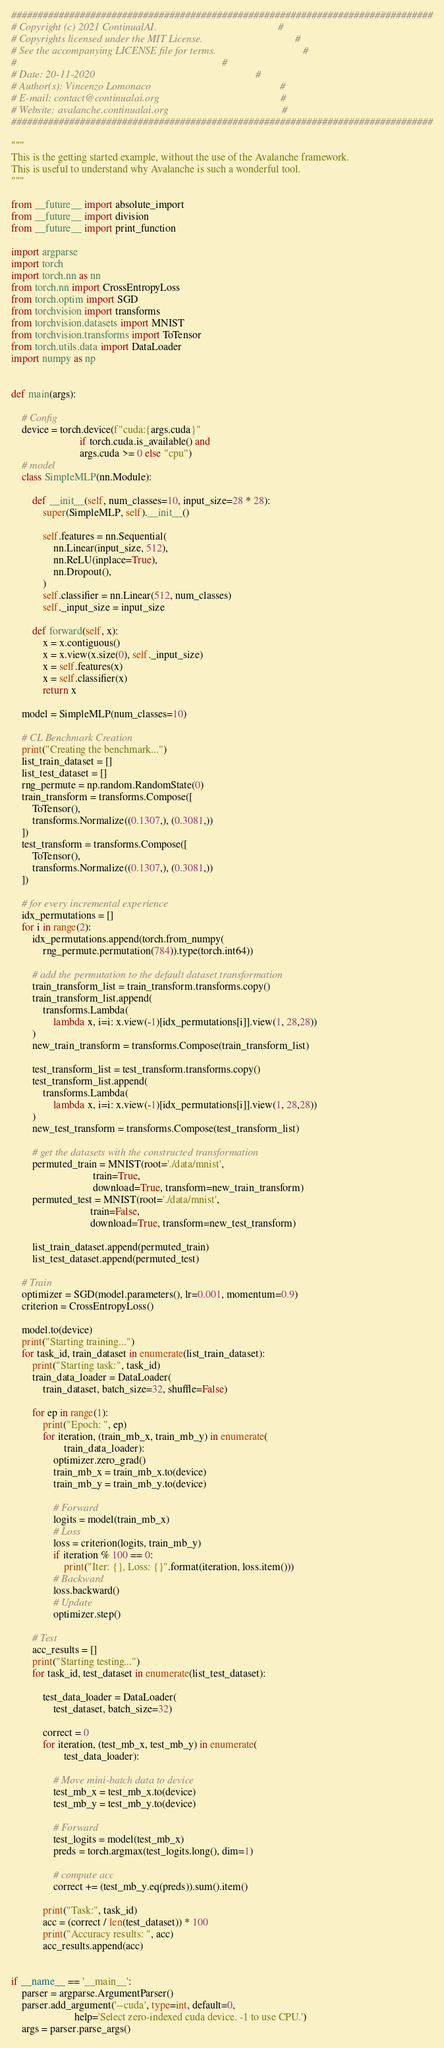<code> <loc_0><loc_0><loc_500><loc_500><_Python_>################################################################################
# Copyright (c) 2021 ContinualAI.                                              #
# Copyrights licensed under the MIT License.                                   #
# See the accompanying LICENSE file for terms.                                 #
#                                                                              #
# Date: 20-11-2020                                                             #
# Author(s): Vincenzo Lomonaco                                                 #
# E-mail: contact@continualai.org                                              #
# Website: avalanche.continualai.org                                           #
################################################################################

"""
This is the getting started example, without the use of the Avalanche framework.
This is useful to understand why Avalanche is such a wonderful tool.
"""

from __future__ import absolute_import
from __future__ import division
from __future__ import print_function

import argparse
import torch
import torch.nn as nn
from torch.nn import CrossEntropyLoss
from torch.optim import SGD
from torchvision import transforms
from torchvision.datasets import MNIST
from torchvision.transforms import ToTensor
from torch.utils.data import DataLoader
import numpy as np


def main(args):

    # Config
    device = torch.device(f"cuda:{args.cuda}"
                          if torch.cuda.is_available() and
                          args.cuda >= 0 else "cpu")
    # model
    class SimpleMLP(nn.Module):

        def __init__(self, num_classes=10, input_size=28 * 28):
            super(SimpleMLP, self).__init__()

            self.features = nn.Sequential(
                nn.Linear(input_size, 512),
                nn.ReLU(inplace=True),
                nn.Dropout(),
            )
            self.classifier = nn.Linear(512, num_classes)
            self._input_size = input_size

        def forward(self, x):
            x = x.contiguous()
            x = x.view(x.size(0), self._input_size)
            x = self.features(x)
            x = self.classifier(x)
            return x

    model = SimpleMLP(num_classes=10)

    # CL Benchmark Creation
    print("Creating the benchmark...")
    list_train_dataset = []
    list_test_dataset = []
    rng_permute = np.random.RandomState(0)
    train_transform = transforms.Compose([
        ToTensor(),
        transforms.Normalize((0.1307,), (0.3081,))
    ])
    test_transform = transforms.Compose([
        ToTensor(),
        transforms.Normalize((0.1307,), (0.3081,))
    ])

    # for every incremental experience
    idx_permutations = []
    for i in range(2):
        idx_permutations.append(torch.from_numpy(
            rng_permute.permutation(784)).type(torch.int64))

        # add the permutation to the default dataset transformation
        train_transform_list = train_transform.transforms.copy()
        train_transform_list.append(
            transforms.Lambda(
                lambda x, i=i: x.view(-1)[idx_permutations[i]].view(1, 28,28))
        )
        new_train_transform = transforms.Compose(train_transform_list)

        test_transform_list = test_transform.transforms.copy()
        test_transform_list.append(
            transforms.Lambda(
                lambda x, i=i: x.view(-1)[idx_permutations[i]].view(1, 28,28))
        )
        new_test_transform = transforms.Compose(test_transform_list)

        # get the datasets with the constructed transformation
        permuted_train = MNIST(root='./data/mnist',
                               train=True,
                               download=True, transform=new_train_transform)
        permuted_test = MNIST(root='./data/mnist',
                              train=False,
                              download=True, transform=new_test_transform)

        list_train_dataset.append(permuted_train)
        list_test_dataset.append(permuted_test)

    # Train
    optimizer = SGD(model.parameters(), lr=0.001, momentum=0.9)
    criterion = CrossEntropyLoss()

    model.to(device)
    print("Starting training...")
    for task_id, train_dataset in enumerate(list_train_dataset):
        print("Starting task:", task_id)
        train_data_loader = DataLoader(
            train_dataset, batch_size=32, shuffle=False)

        for ep in range(1):
            print("Epoch: ", ep)
            for iteration, (train_mb_x, train_mb_y) in enumerate(
                    train_data_loader):
                optimizer.zero_grad()
                train_mb_x = train_mb_x.to(device)
                train_mb_y = train_mb_y.to(device)

                # Forward
                logits = model(train_mb_x)
                # Loss
                loss = criterion(logits, train_mb_y)
                if iteration % 100 == 0:
                    print("Iter: {}, Loss: {}".format(iteration, loss.item()))
                # Backward
                loss.backward()
                # Update
                optimizer.step()

        # Test
        acc_results = []
        print("Starting testing...")
        for task_id, test_dataset in enumerate(list_test_dataset):

            test_data_loader = DataLoader(
                test_dataset, batch_size=32)

            correct = 0
            for iteration, (test_mb_x, test_mb_y) in enumerate(
                    test_data_loader):

                # Move mini-batch data to device
                test_mb_x = test_mb_x.to(device)
                test_mb_y = test_mb_y.to(device)

                # Forward
                test_logits = model(test_mb_x)
                preds = torch.argmax(test_logits.long(), dim=1)

                # compute acc
                correct += (test_mb_y.eq(preds)).sum().item()

            print("Task:", task_id)
            acc = (correct / len(test_dataset)) * 100
            print("Accuracy results: ", acc)
            acc_results.append(acc)


if __name__ == '__main__':
    parser = argparse.ArgumentParser()
    parser.add_argument('--cuda', type=int, default=0,
                        help='Select zero-indexed cuda device. -1 to use CPU.')
    args = parser.parse_args()</code> 